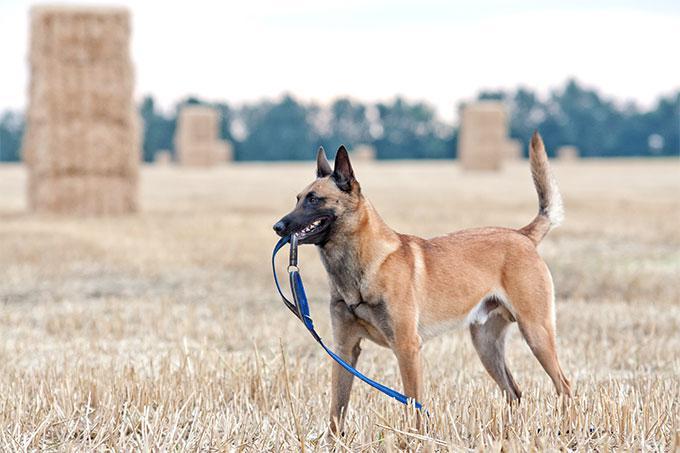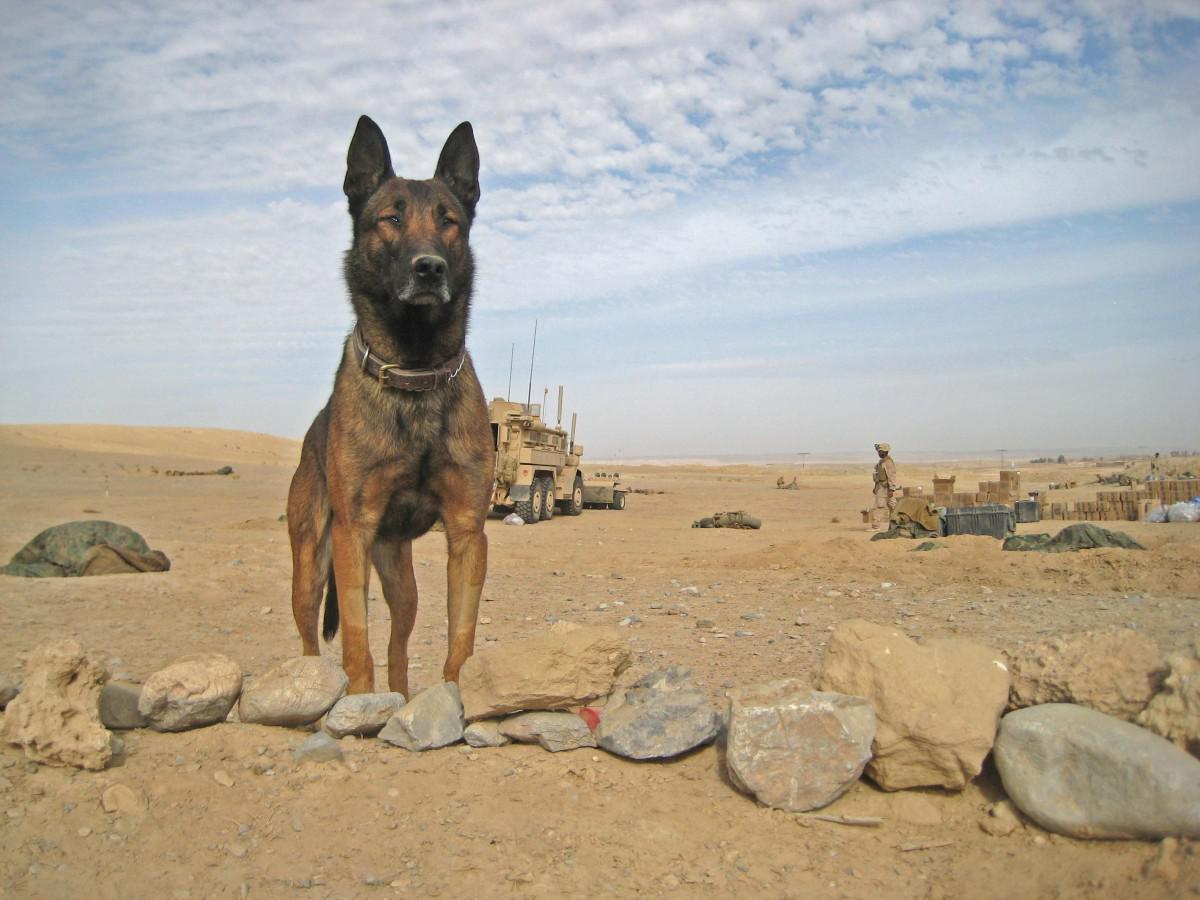The first image is the image on the left, the second image is the image on the right. Given the left and right images, does the statement "In one of the images, a dog is wearing a leash attached to a collar" hold true? Answer yes or no. No. 